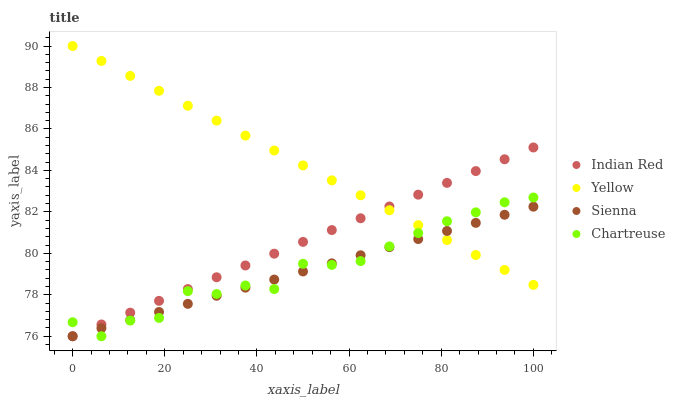Does Sienna have the minimum area under the curve?
Answer yes or no. Yes. Does Yellow have the maximum area under the curve?
Answer yes or no. Yes. Does Chartreuse have the minimum area under the curve?
Answer yes or no. No. Does Chartreuse have the maximum area under the curve?
Answer yes or no. No. Is Yellow the smoothest?
Answer yes or no. Yes. Is Chartreuse the roughest?
Answer yes or no. Yes. Is Chartreuse the smoothest?
Answer yes or no. No. Is Yellow the roughest?
Answer yes or no. No. Does Sienna have the lowest value?
Answer yes or no. Yes. Does Yellow have the lowest value?
Answer yes or no. No. Does Yellow have the highest value?
Answer yes or no. Yes. Does Chartreuse have the highest value?
Answer yes or no. No. Does Chartreuse intersect Indian Red?
Answer yes or no. Yes. Is Chartreuse less than Indian Red?
Answer yes or no. No. Is Chartreuse greater than Indian Red?
Answer yes or no. No. 